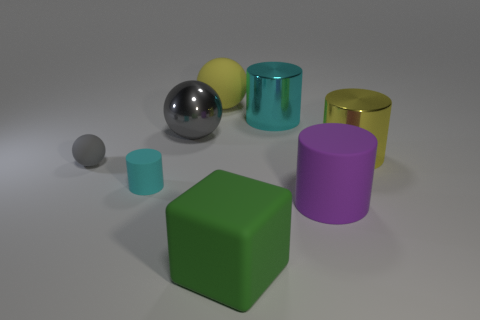Subtract 3 balls. How many balls are left? 0 Add 2 large gray shiny things. How many objects exist? 10 Subtract all yellow balls. How many balls are left? 2 Subtract all big purple matte cylinders. How many cylinders are left? 3 Subtract all gray blocks. How many yellow balls are left? 1 Subtract all big yellow things. Subtract all big cylinders. How many objects are left? 3 Add 1 tiny cylinders. How many tiny cylinders are left? 2 Add 4 big cyan shiny cylinders. How many big cyan shiny cylinders exist? 5 Subtract 0 purple spheres. How many objects are left? 8 Subtract all cubes. How many objects are left? 7 